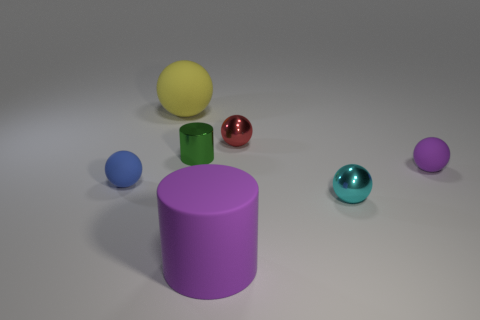Subtract 1 balls. How many balls are left? 4 Subtract all yellow rubber spheres. How many spheres are left? 4 Subtract all yellow balls. How many balls are left? 4 Subtract all brown balls. Subtract all yellow cubes. How many balls are left? 5 Add 1 small brown metal cylinders. How many objects exist? 8 Subtract all cylinders. How many objects are left? 5 Subtract 1 red spheres. How many objects are left? 6 Subtract all metal objects. Subtract all purple matte objects. How many objects are left? 2 Add 6 tiny cyan metal things. How many tiny cyan metal things are left? 7 Add 1 purple cylinders. How many purple cylinders exist? 2 